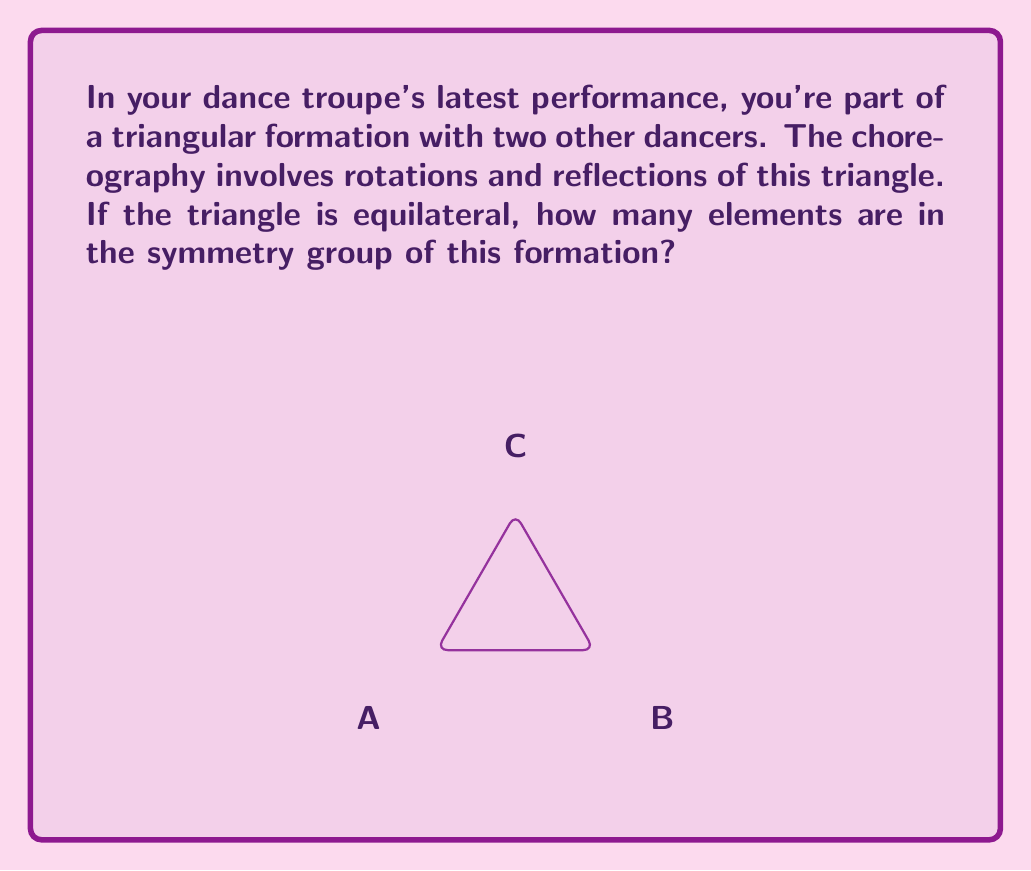Show me your answer to this math problem. Let's approach this step-by-step:

1) The symmetry group of an equilateral triangle is known as the dihedral group $D_3$.

2) To determine the number of elements in $D_3$, we need to count all possible symmetries:

   a) Rotations:
      - Identity (no rotation)
      - Rotation by 120° clockwise
      - Rotation by 240° clockwise (or 120° counterclockwise)

   b) Reflections:
      - Reflection across the altitude from A
      - Reflection across the altitude from B
      - Reflection across the altitude from C

3) Let's count:
   - 3 rotations (including identity)
   - 3 reflections

4) In total, we have 3 + 3 = 6 symmetries.

5) Therefore, the order of the symmetry group $D_3$ is 6.

This means that during your dance, there are 6 different ways the triangular formation can be symmetrically arranged through rotations and reflections.
Answer: 6 